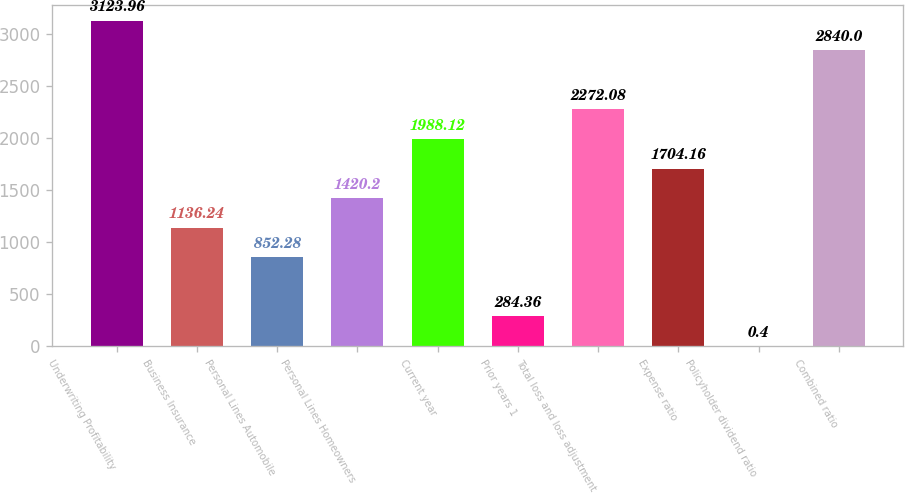<chart> <loc_0><loc_0><loc_500><loc_500><bar_chart><fcel>Underwriting Profitability<fcel>Business Insurance<fcel>Personal Lines Automobile<fcel>Personal Lines Homeowners<fcel>Current year<fcel>Prior years 1<fcel>Total loss and loss adjustment<fcel>Expense ratio<fcel>Policyholder dividend ratio<fcel>Combined ratio<nl><fcel>3123.96<fcel>1136.24<fcel>852.28<fcel>1420.2<fcel>1988.12<fcel>284.36<fcel>2272.08<fcel>1704.16<fcel>0.4<fcel>2840<nl></chart> 